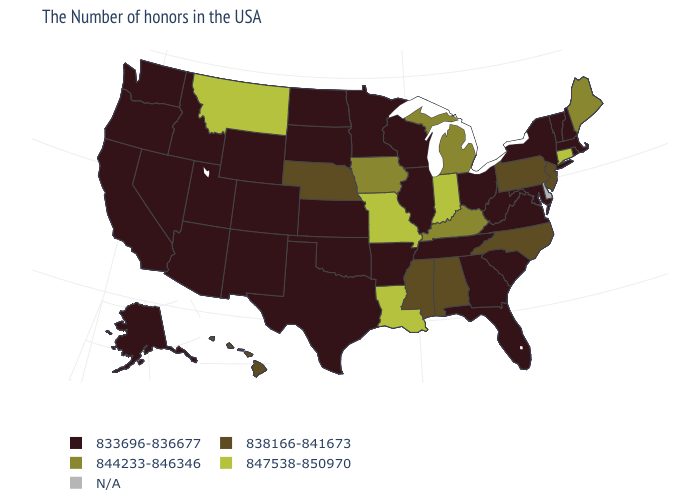Among the states that border New Jersey , which have the lowest value?
Write a very short answer. New York. Does the map have missing data?
Keep it brief. Yes. Which states have the lowest value in the USA?
Give a very brief answer. Massachusetts, Rhode Island, New Hampshire, Vermont, New York, Maryland, Virginia, South Carolina, West Virginia, Ohio, Florida, Georgia, Tennessee, Wisconsin, Illinois, Arkansas, Minnesota, Kansas, Oklahoma, Texas, South Dakota, North Dakota, Wyoming, Colorado, New Mexico, Utah, Arizona, Idaho, Nevada, California, Washington, Oregon, Alaska. Does the map have missing data?
Be succinct. Yes. Which states hav the highest value in the West?
Give a very brief answer. Montana. Does the first symbol in the legend represent the smallest category?
Quick response, please. Yes. What is the value of New Hampshire?
Give a very brief answer. 833696-836677. Name the states that have a value in the range 844233-846346?
Be succinct. Maine, Michigan, Kentucky, Iowa. What is the highest value in the USA?
Quick response, please. 847538-850970. What is the value of New Mexico?
Give a very brief answer. 833696-836677. Which states have the highest value in the USA?
Answer briefly. Connecticut, Indiana, Louisiana, Missouri, Montana. Name the states that have a value in the range N/A?
Give a very brief answer. Delaware. 